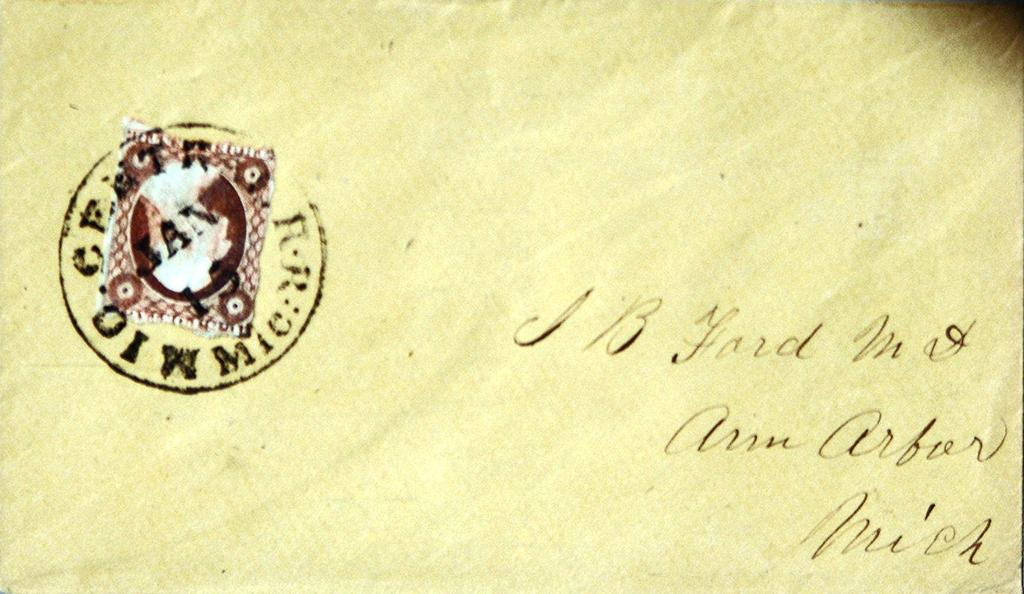<image>
Summarize the visual content of the image. the name Arbor is on the side of a note 